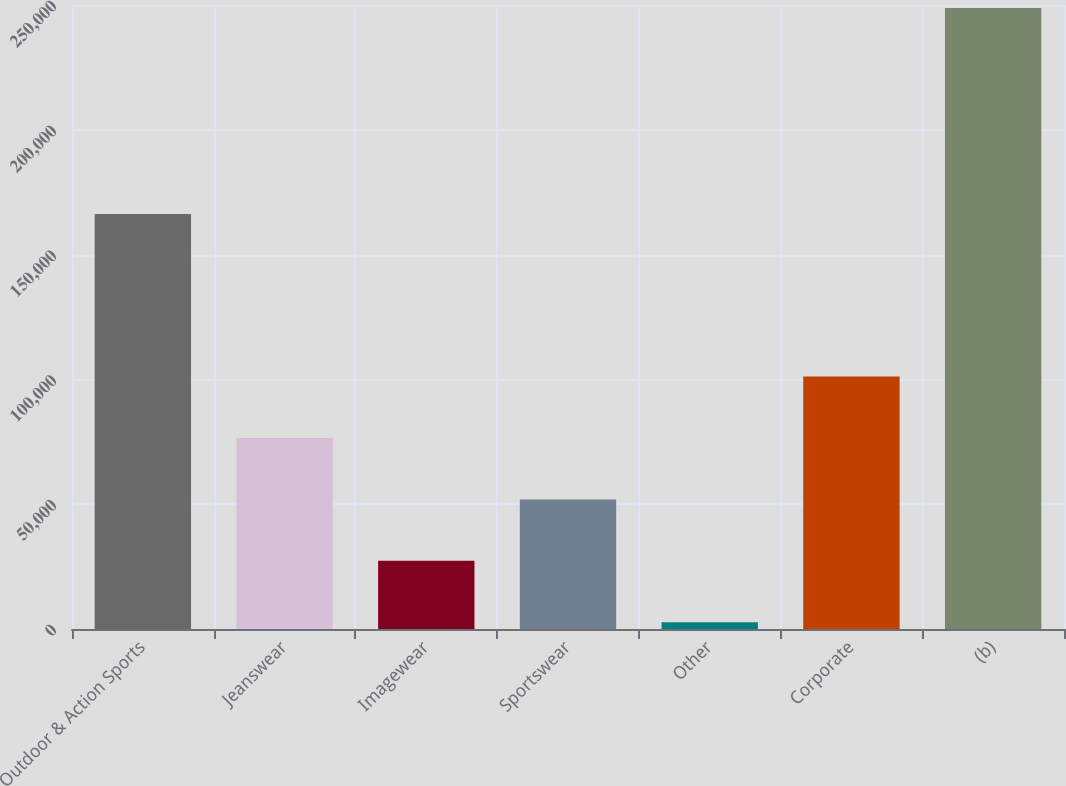Convert chart to OTSL. <chart><loc_0><loc_0><loc_500><loc_500><bar_chart><fcel>Outdoor & Action Sports<fcel>Jeanswear<fcel>Imagewear<fcel>Sportswear<fcel>Other<fcel>Corporate<fcel>(b)<nl><fcel>166267<fcel>76526.7<fcel>27294.9<fcel>51910.8<fcel>2679<fcel>101143<fcel>248838<nl></chart> 